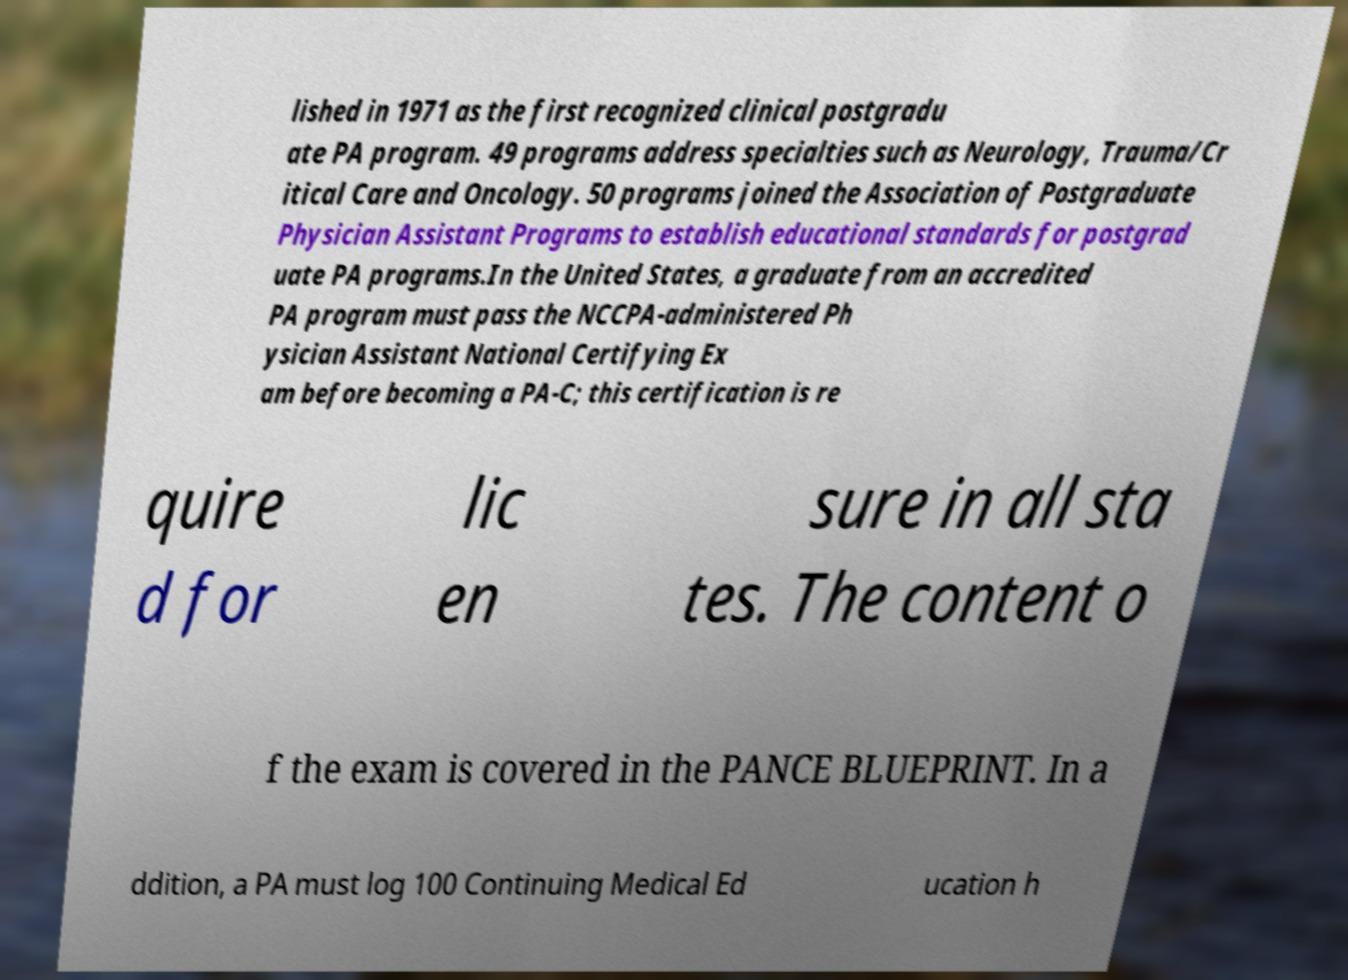I need the written content from this picture converted into text. Can you do that? lished in 1971 as the first recognized clinical postgradu ate PA program. 49 programs address specialties such as Neurology, Trauma/Cr itical Care and Oncology. 50 programs joined the Association of Postgraduate Physician Assistant Programs to establish educational standards for postgrad uate PA programs.In the United States, a graduate from an accredited PA program must pass the NCCPA-administered Ph ysician Assistant National Certifying Ex am before becoming a PA-C; this certification is re quire d for lic en sure in all sta tes. The content o f the exam is covered in the PANCE BLUEPRINT. In a ddition, a PA must log 100 Continuing Medical Ed ucation h 